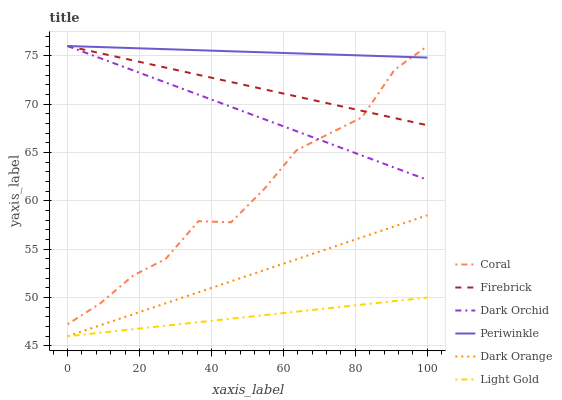Does Light Gold have the minimum area under the curve?
Answer yes or no. Yes. Does Periwinkle have the maximum area under the curve?
Answer yes or no. Yes. Does Coral have the minimum area under the curve?
Answer yes or no. No. Does Coral have the maximum area under the curve?
Answer yes or no. No. Is Periwinkle the smoothest?
Answer yes or no. Yes. Is Coral the roughest?
Answer yes or no. Yes. Is Dark Orchid the smoothest?
Answer yes or no. No. Is Dark Orchid the roughest?
Answer yes or no. No. Does Dark Orange have the lowest value?
Answer yes or no. Yes. Does Coral have the lowest value?
Answer yes or no. No. Does Firebrick have the highest value?
Answer yes or no. Yes. Does Light Gold have the highest value?
Answer yes or no. No. Is Dark Orange less than Coral?
Answer yes or no. Yes. Is Firebrick greater than Light Gold?
Answer yes or no. Yes. Does Periwinkle intersect Firebrick?
Answer yes or no. Yes. Is Periwinkle less than Firebrick?
Answer yes or no. No. Is Periwinkle greater than Firebrick?
Answer yes or no. No. Does Dark Orange intersect Coral?
Answer yes or no. No. 